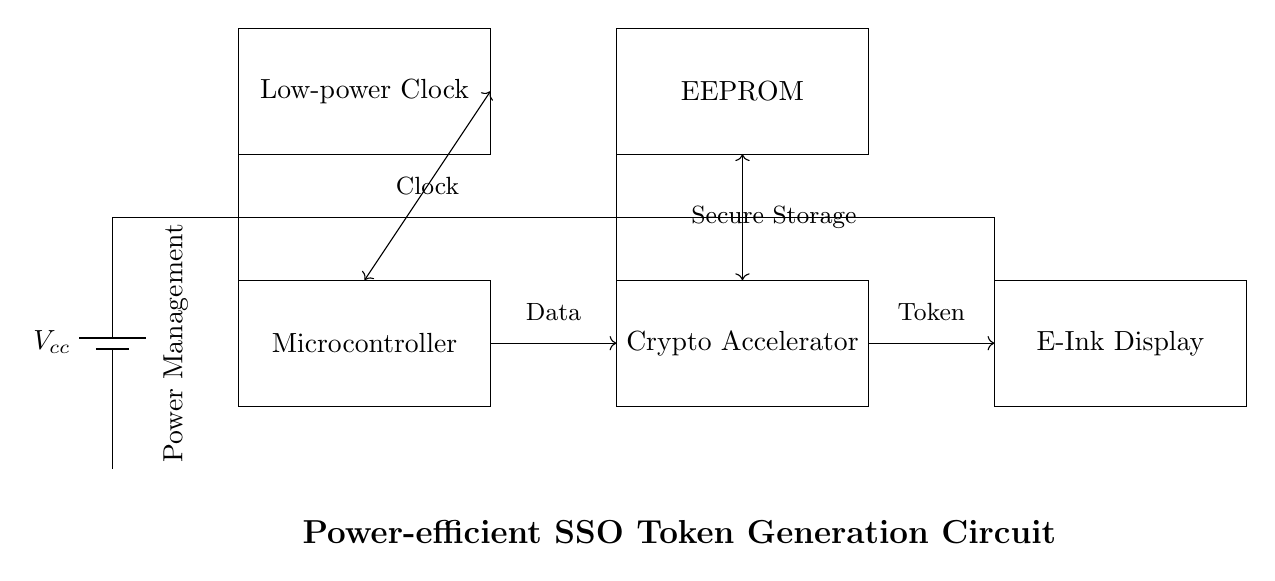What is the power source in this circuit? The power source is labeled as Vcc and is represented as a battery symbol in the diagram.
Answer: Vcc How many main components are present in the circuit? There are five main components: Power Management, Microcontroller, Crypto Accelerator, EEPROM, and E-Ink Display.
Answer: Five What type of display is used in this circuit? The display used in the circuit is labeled as an E-Ink Display.
Answer: E-Ink Display Which component manages the clock signals? The Low-power Clock component manages the clock signals, as indicated by its labeling in the diagram.
Answer: Low-power Clock What type of data processing does the Crypto Accelerator perform? The Crypto Accelerator is responsible for secure token generation and validation, indicated by its placement in the circuit and connection to the Microcontroller.
Answer: Secure token generation and validation How does the Microcontroller connect to the Crypto Accelerator? The Microcontroller connects to the Crypto Accelerator through a direct data connection, represented by an arrow indicating the direction of data flow in the diagram.
Answer: Direct data connection 